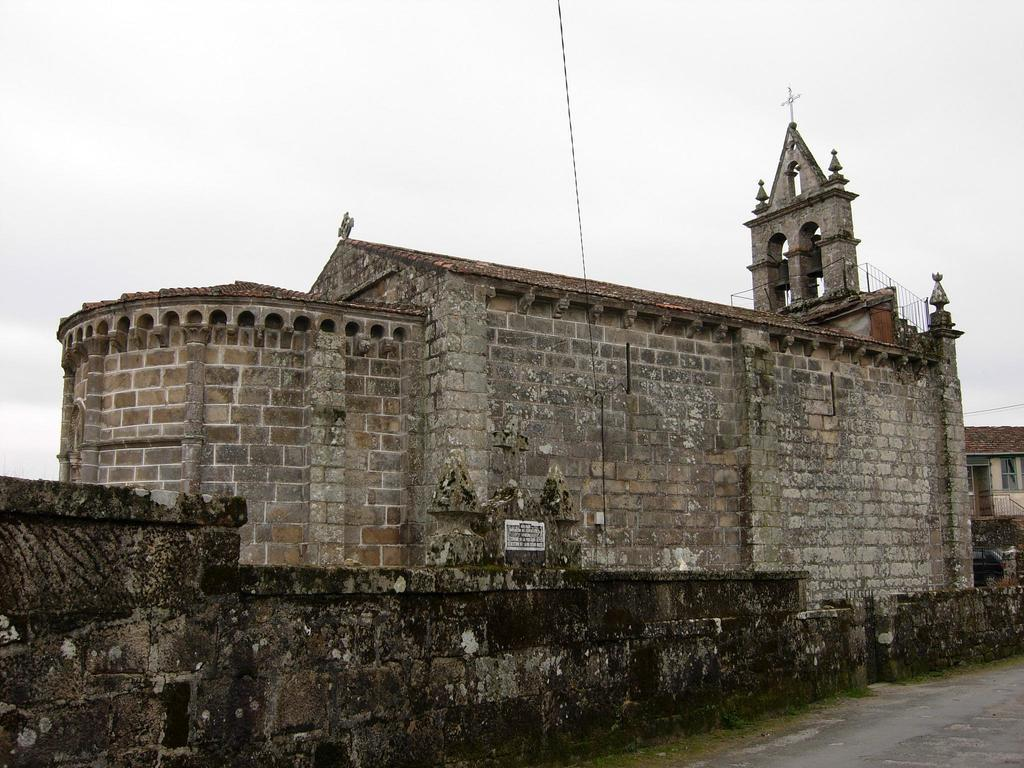What type of structure is present in the image? There is a building in the image. What feature can be seen on the building? The building has railing. What religious symbol is visible in the image? There is a cross in the image. What type of surface is present for walking or moving in the image? There is a pathway in the image. What is visible in the background of the image? The sky is visible in the image. How would you describe the weather based on the appearance of the sky? The sky appears cloudy in the image. What thrilling performance can be seen taking place near the building in the image? There is no thrilling performance taking place near the building in the image. Can you identify the famous actor standing next to the cross in the image? There is no actor present in the image, and the cross is not associated with a person. How many spiders are crawling on the railing of the building in the image? There are no spiders visible on the railing of the building in the image. 